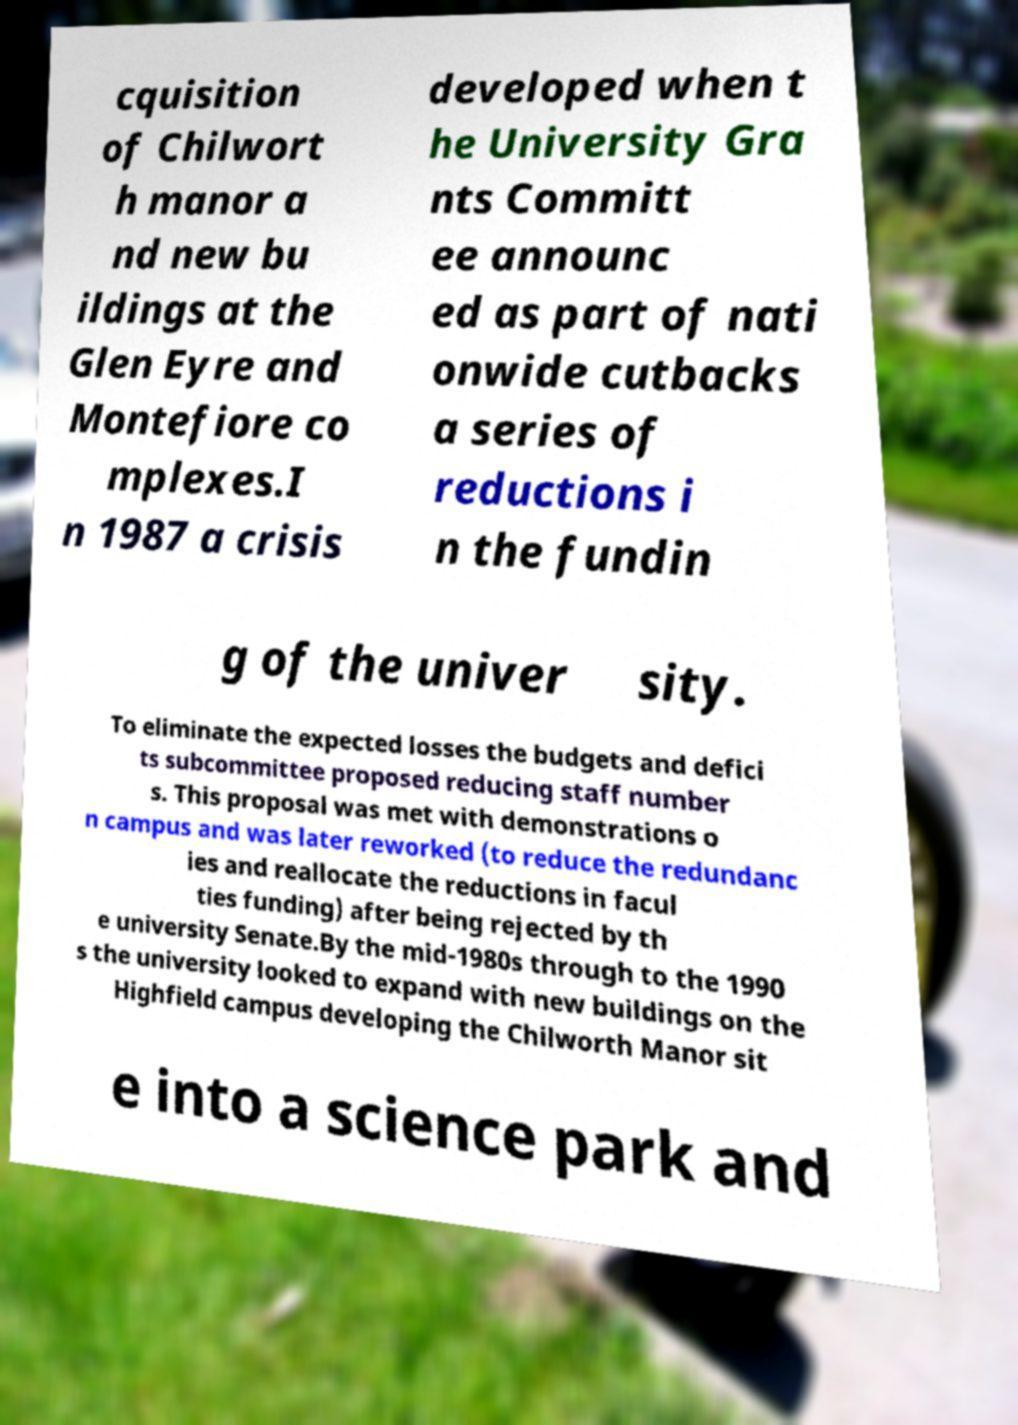Can you accurately transcribe the text from the provided image for me? cquisition of Chilwort h manor a nd new bu ildings at the Glen Eyre and Montefiore co mplexes.I n 1987 a crisis developed when t he University Gra nts Committ ee announc ed as part of nati onwide cutbacks a series of reductions i n the fundin g of the univer sity. To eliminate the expected losses the budgets and defici ts subcommittee proposed reducing staff number s. This proposal was met with demonstrations o n campus and was later reworked (to reduce the redundanc ies and reallocate the reductions in facul ties funding) after being rejected by th e university Senate.By the mid-1980s through to the 1990 s the university looked to expand with new buildings on the Highfield campus developing the Chilworth Manor sit e into a science park and 